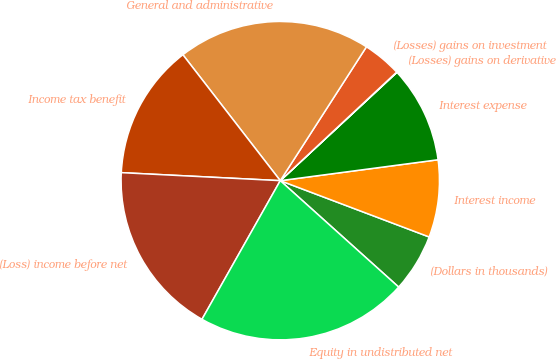Convert chart. <chart><loc_0><loc_0><loc_500><loc_500><pie_chart><fcel>(Dollars in thousands)<fcel>Interest income<fcel>Interest expense<fcel>(Losses) gains on derivative<fcel>(Losses) gains on investment<fcel>General and administrative<fcel>Income tax benefit<fcel>(Loss) income before net<fcel>Equity in undistributed net<nl><fcel>5.9%<fcel>7.85%<fcel>9.81%<fcel>0.04%<fcel>3.95%<fcel>19.58%<fcel>13.72%<fcel>17.62%<fcel>21.53%<nl></chart> 